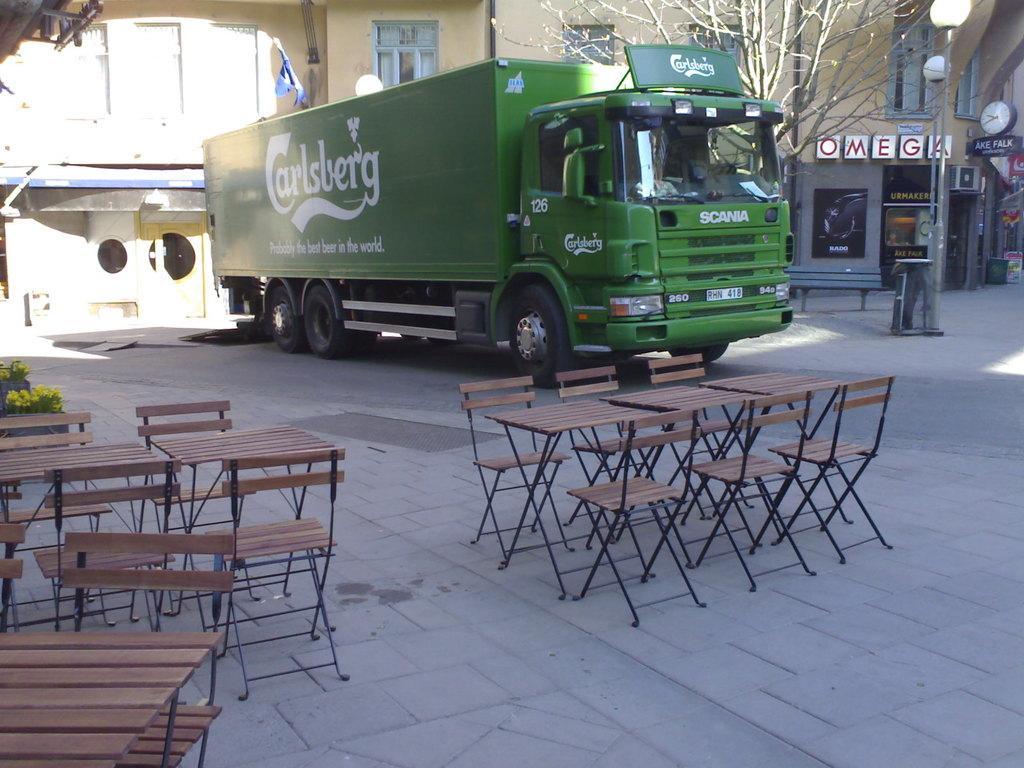Please provide a concise description of this image. This picture shows a truck and house and few chairs and tables and a tree 